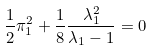<formula> <loc_0><loc_0><loc_500><loc_500>\frac { 1 } { 2 } \pi _ { 1 } ^ { 2 } + \frac { 1 } { 8 } \frac { \lambda _ { 1 } ^ { 2 } } { \lambda _ { 1 } - 1 } = 0</formula> 